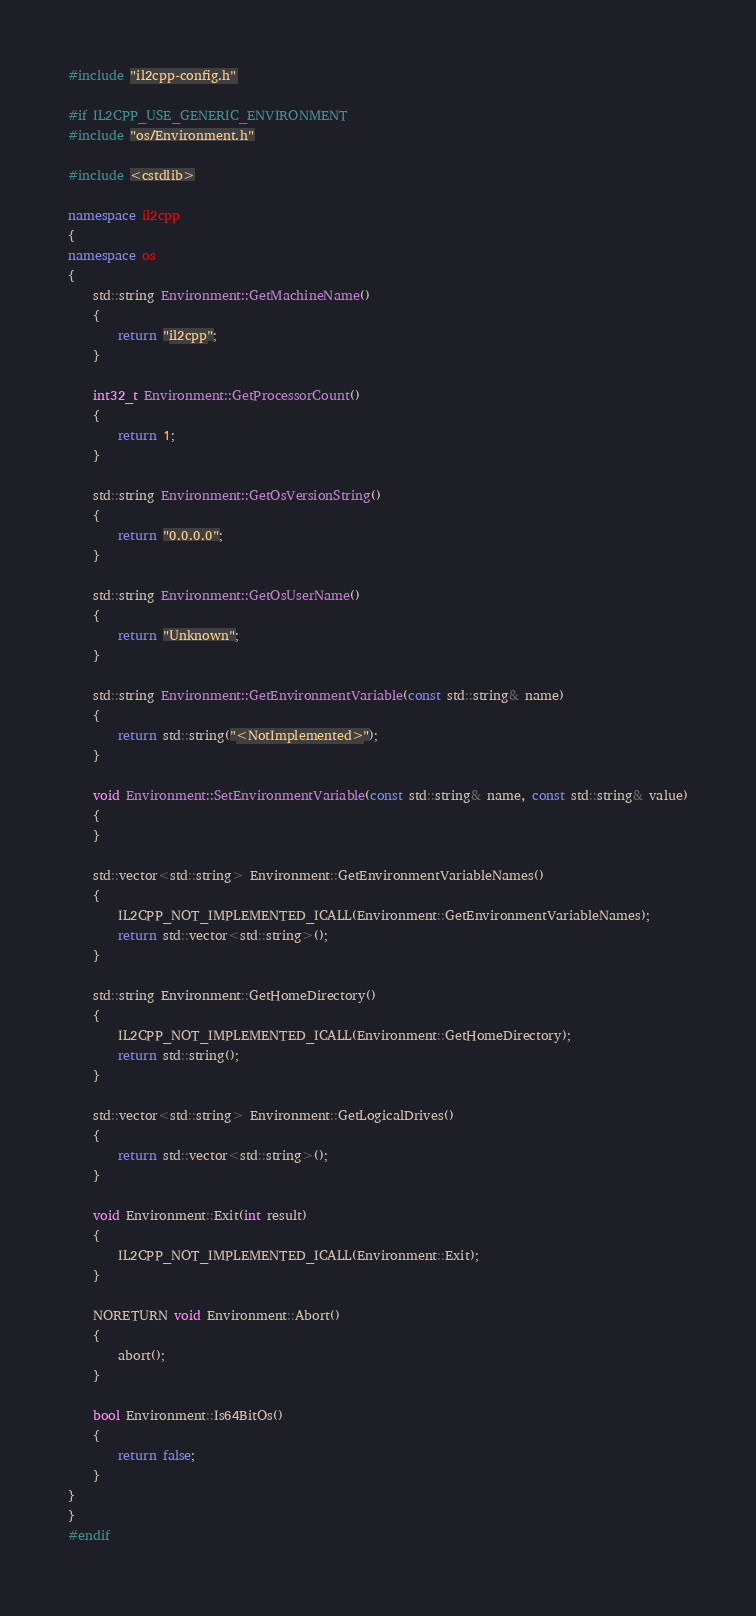<code> <loc_0><loc_0><loc_500><loc_500><_C++_>#include "il2cpp-config.h"

#if IL2CPP_USE_GENERIC_ENVIRONMENT
#include "os/Environment.h"

#include <cstdlib>

namespace il2cpp
{
namespace os
{
    std::string Environment::GetMachineName()
    {
        return "il2cpp";
    }

    int32_t Environment::GetProcessorCount()
    {
        return 1;
    }

    std::string Environment::GetOsVersionString()
    {
        return "0.0.0.0";
    }

    std::string Environment::GetOsUserName()
    {
        return "Unknown";
    }

    std::string Environment::GetEnvironmentVariable(const std::string& name)
    {
        return std::string("<NotImplemented>");
    }

    void Environment::SetEnvironmentVariable(const std::string& name, const std::string& value)
    {
    }

    std::vector<std::string> Environment::GetEnvironmentVariableNames()
    {
        IL2CPP_NOT_IMPLEMENTED_ICALL(Environment::GetEnvironmentVariableNames);
        return std::vector<std::string>();
    }

    std::string Environment::GetHomeDirectory()
    {
        IL2CPP_NOT_IMPLEMENTED_ICALL(Environment::GetHomeDirectory);
        return std::string();
    }

    std::vector<std::string> Environment::GetLogicalDrives()
    {
        return std::vector<std::string>();
    }

    void Environment::Exit(int result)
    {
        IL2CPP_NOT_IMPLEMENTED_ICALL(Environment::Exit);
    }

    NORETURN void Environment::Abort()
    {
        abort();
    }

    bool Environment::Is64BitOs()
    {
        return false;
    }
}
}
#endif
</code> 